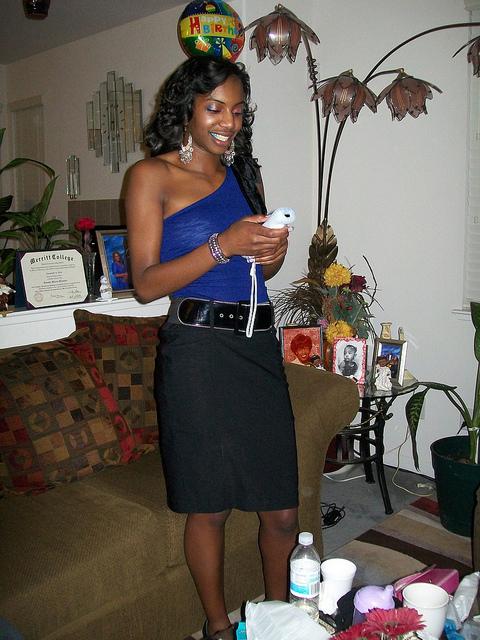Is this woman getting drunk?
Short answer required. No. Is this taken at a restaurant?
Write a very short answer. No. What is the man holding?
Answer briefly. Wii remote. Does the room have good feng shui?
Give a very brief answer. No. Is this woman wearing a white shirt?
Write a very short answer. No. Is this a restaurant?
Short answer required. No. Is there a mirror in this picture?
Be succinct. No. 